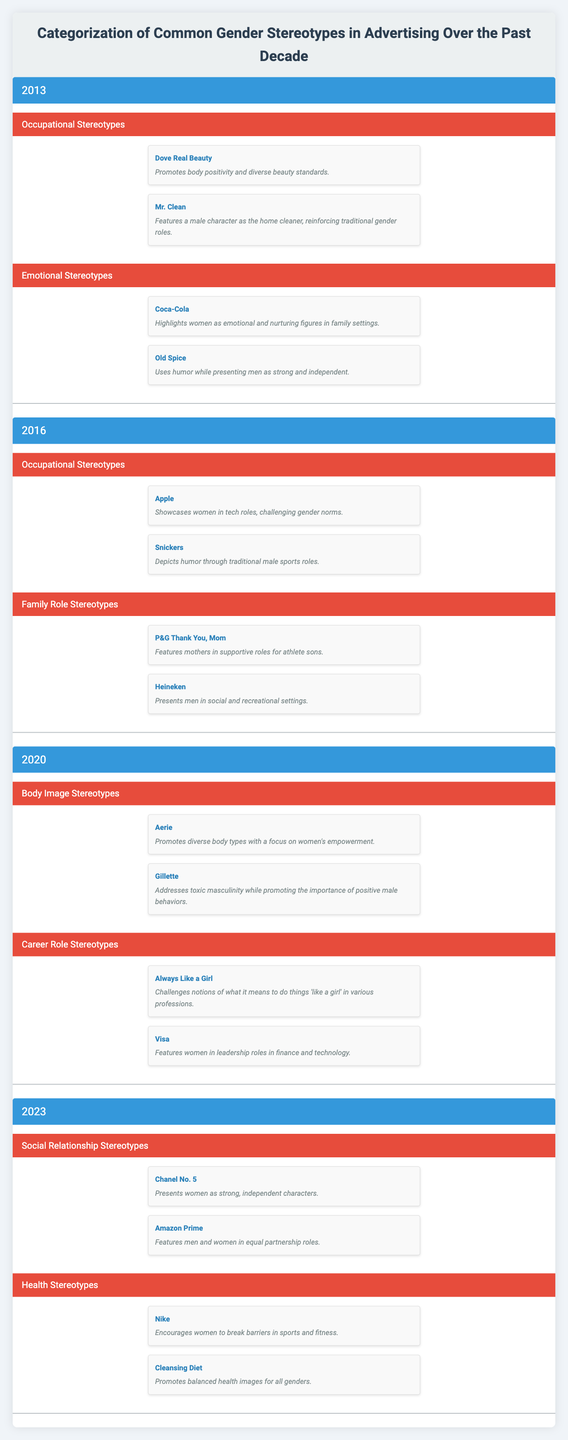What are the emotional stereotypes depicted in advertising in 2013? In 2013, the emotional stereotypes depicted in advertising include the Coca-Cola campaign, which highlights women as emotional and nurturing figures in family settings, and the Old Spice campaign, which presents men as strong and independent using humor.
Answer: Coca-Cola and Old Spice How many distinct categories of gender stereotypes were identified in the advertising data for 2020? The advertising data for 2020 identifies two distinct categories of gender stereotypes: Body Image Stereotypes and Career Role Stereotypes.
Answer: Two Does the Apple ad campaign portray women in traditional roles? No, the Apple ad campaign showcases women in tech roles, which challenges traditional gender norms.
Answer: No Which year shows a shift from occupational stereotypes to family role stereotypes in advertisements? In 2016, there is a clear distinction where the focus shifts from purely occupational stereotypes, as seen in the 2013 and 2016 categories, to including family role stereotypes, which are highlighted in its own category.
Answer: 2016 What is the most recent ad campaign that promotes women’s empowerment in body image? The most recent ad campaign promoting women's empowerment in body image is Aerie, which highlights diverse body types.
Answer: Aerie In which year did the Gillette campaign address masculinity, and how does it relate to toxic masculinity? The Gillette campaign addresses toxic masculinity in 2020, focusing on the importance of positive male behaviors in contrast to traditional, toxic male stereotypes.
Answer: 2020 Are there more advertisements featuring men than women across the years provided? No, the examples from each year show that there are an equal or greater number of advertisements showcasing women when considering the positive portrayal of women's empowerment and roles in the examples given.
Answer: No Which categories were highlighted in the advertising stereotypes for 2023? In 2023, the highlighted categories are Social Relationship Stereotypes and Health Stereotypes.
Answer: Social Relationship Stereotypes and Health Stereotypes What percentage of ad campaigns from 2013 and 2020 promote positive portrayals or challenge stereotypes? Analyzing from 2013, the Dove Real Beauty promotes body positivity (1 out of 2), and in 2020, both Aerie and Always Like a Girl challenge stereotypes (2 out of 4). This gives us (1+2)/(2+4) = 3/6 = 0.5, or 50%.
Answer: 50% 